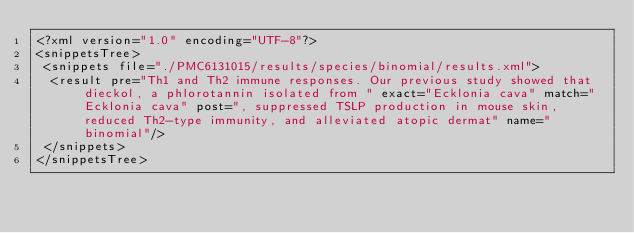<code> <loc_0><loc_0><loc_500><loc_500><_XML_><?xml version="1.0" encoding="UTF-8"?>
<snippetsTree>
 <snippets file="./PMC6131015/results/species/binomial/results.xml">
  <result pre="Th1 and Th2 immune responses. Our previous study showed that dieckol, a phlorotannin isolated from " exact="Ecklonia cava" match="Ecklonia cava" post=", suppressed TSLP production in mouse skin, reduced Th2-type immunity, and alleviated atopic dermat" name="binomial"/>
 </snippets>
</snippetsTree>
</code> 